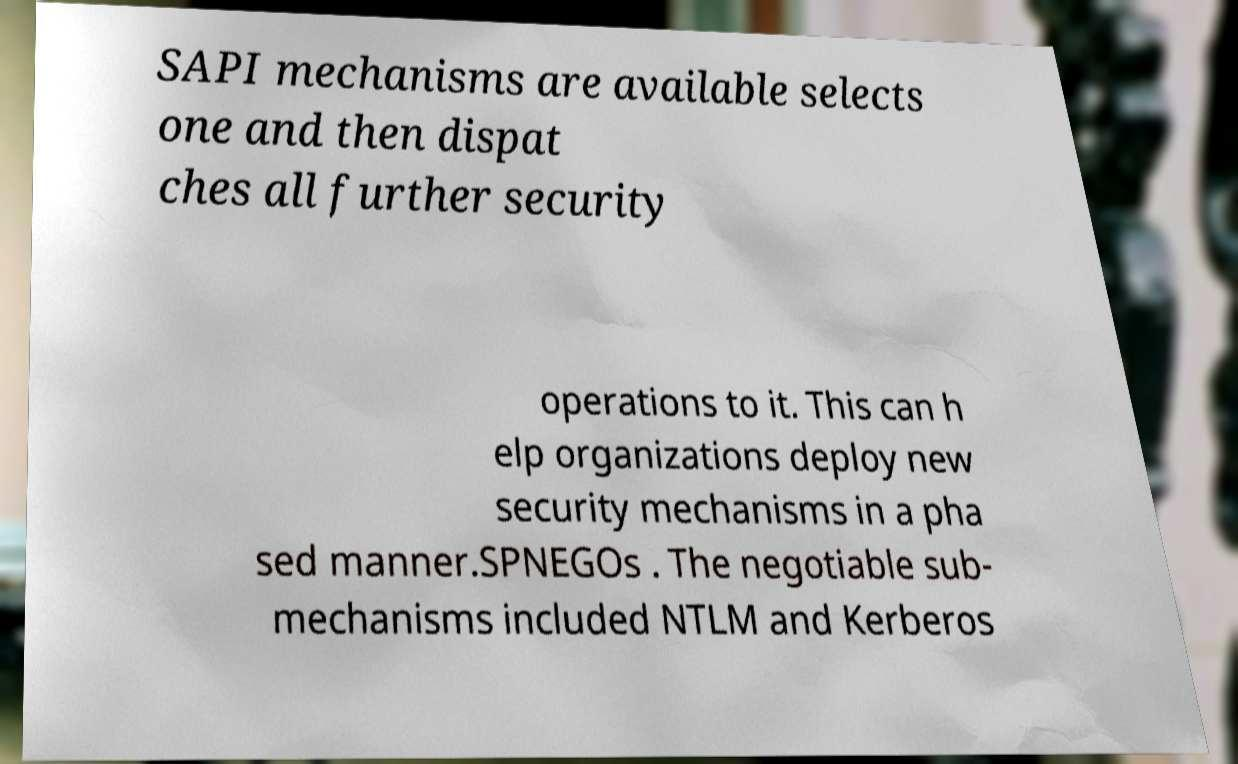Could you extract and type out the text from this image? SAPI mechanisms are available selects one and then dispat ches all further security operations to it. This can h elp organizations deploy new security mechanisms in a pha sed manner.SPNEGOs . The negotiable sub- mechanisms included NTLM and Kerberos 